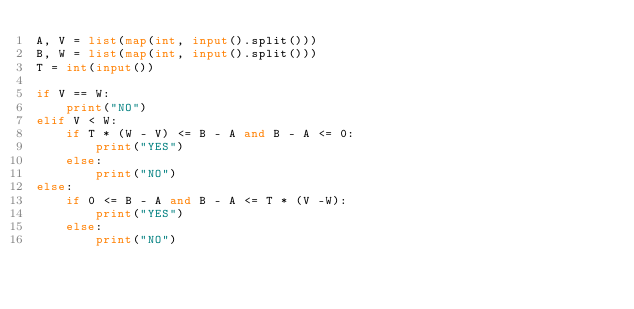Convert code to text. <code><loc_0><loc_0><loc_500><loc_500><_Python_>A, V = list(map(int, input().split()))
B, W = list(map(int, input().split()))
T = int(input())

if V == W:
    print("NO")
elif V < W:
    if T * (W - V) <= B - A and B - A <= 0:
        print("YES")
    else:
        print("NO")
else:
    if 0 <= B - A and B - A <= T * (V -W):
        print("YES")
    else:
        print("NO")</code> 